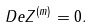Convert formula to latex. <formula><loc_0><loc_0><loc_500><loc_500>\ D e Z ^ { ( m ) } = 0 .</formula> 